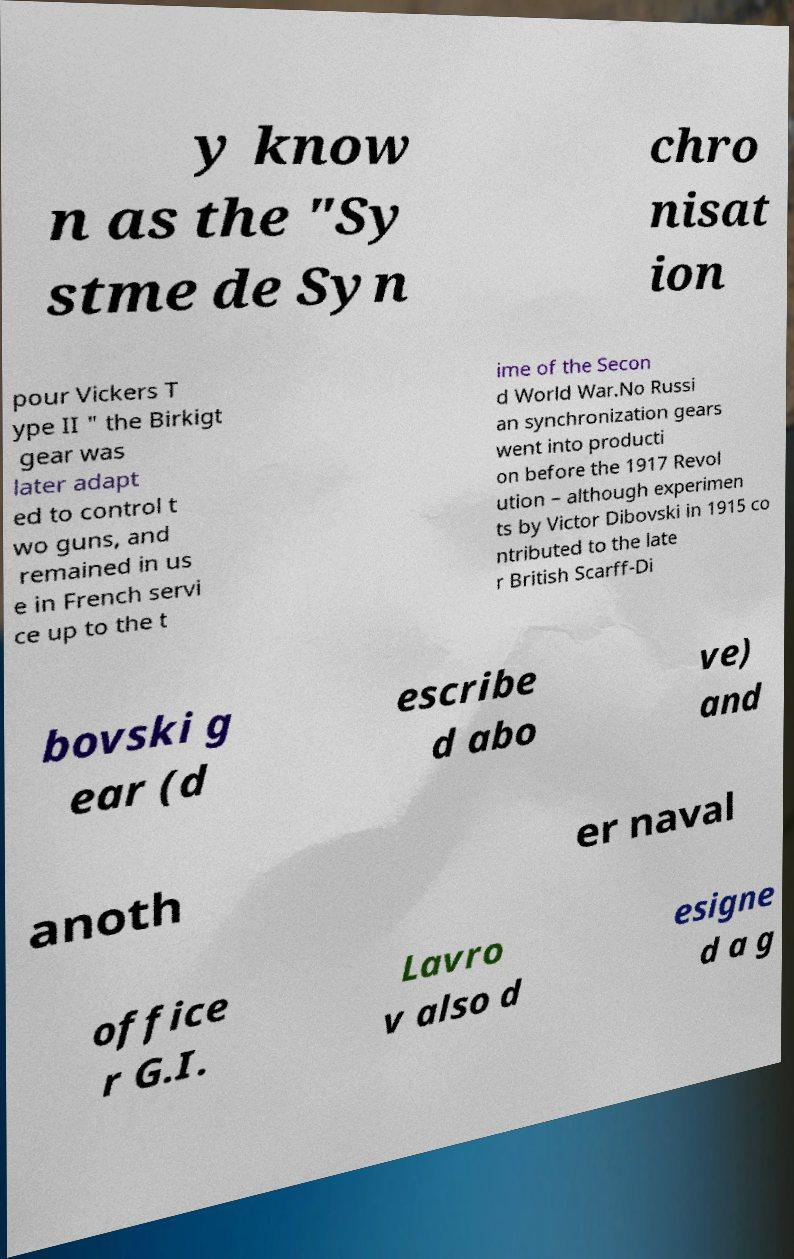I need the written content from this picture converted into text. Can you do that? y know n as the "Sy stme de Syn chro nisat ion pour Vickers T ype II " the Birkigt gear was later adapt ed to control t wo guns, and remained in us e in French servi ce up to the t ime of the Secon d World War.No Russi an synchronization gears went into producti on before the 1917 Revol ution – although experimen ts by Victor Dibovski in 1915 co ntributed to the late r British Scarff-Di bovski g ear (d escribe d abo ve) and anoth er naval office r G.I. Lavro v also d esigne d a g 